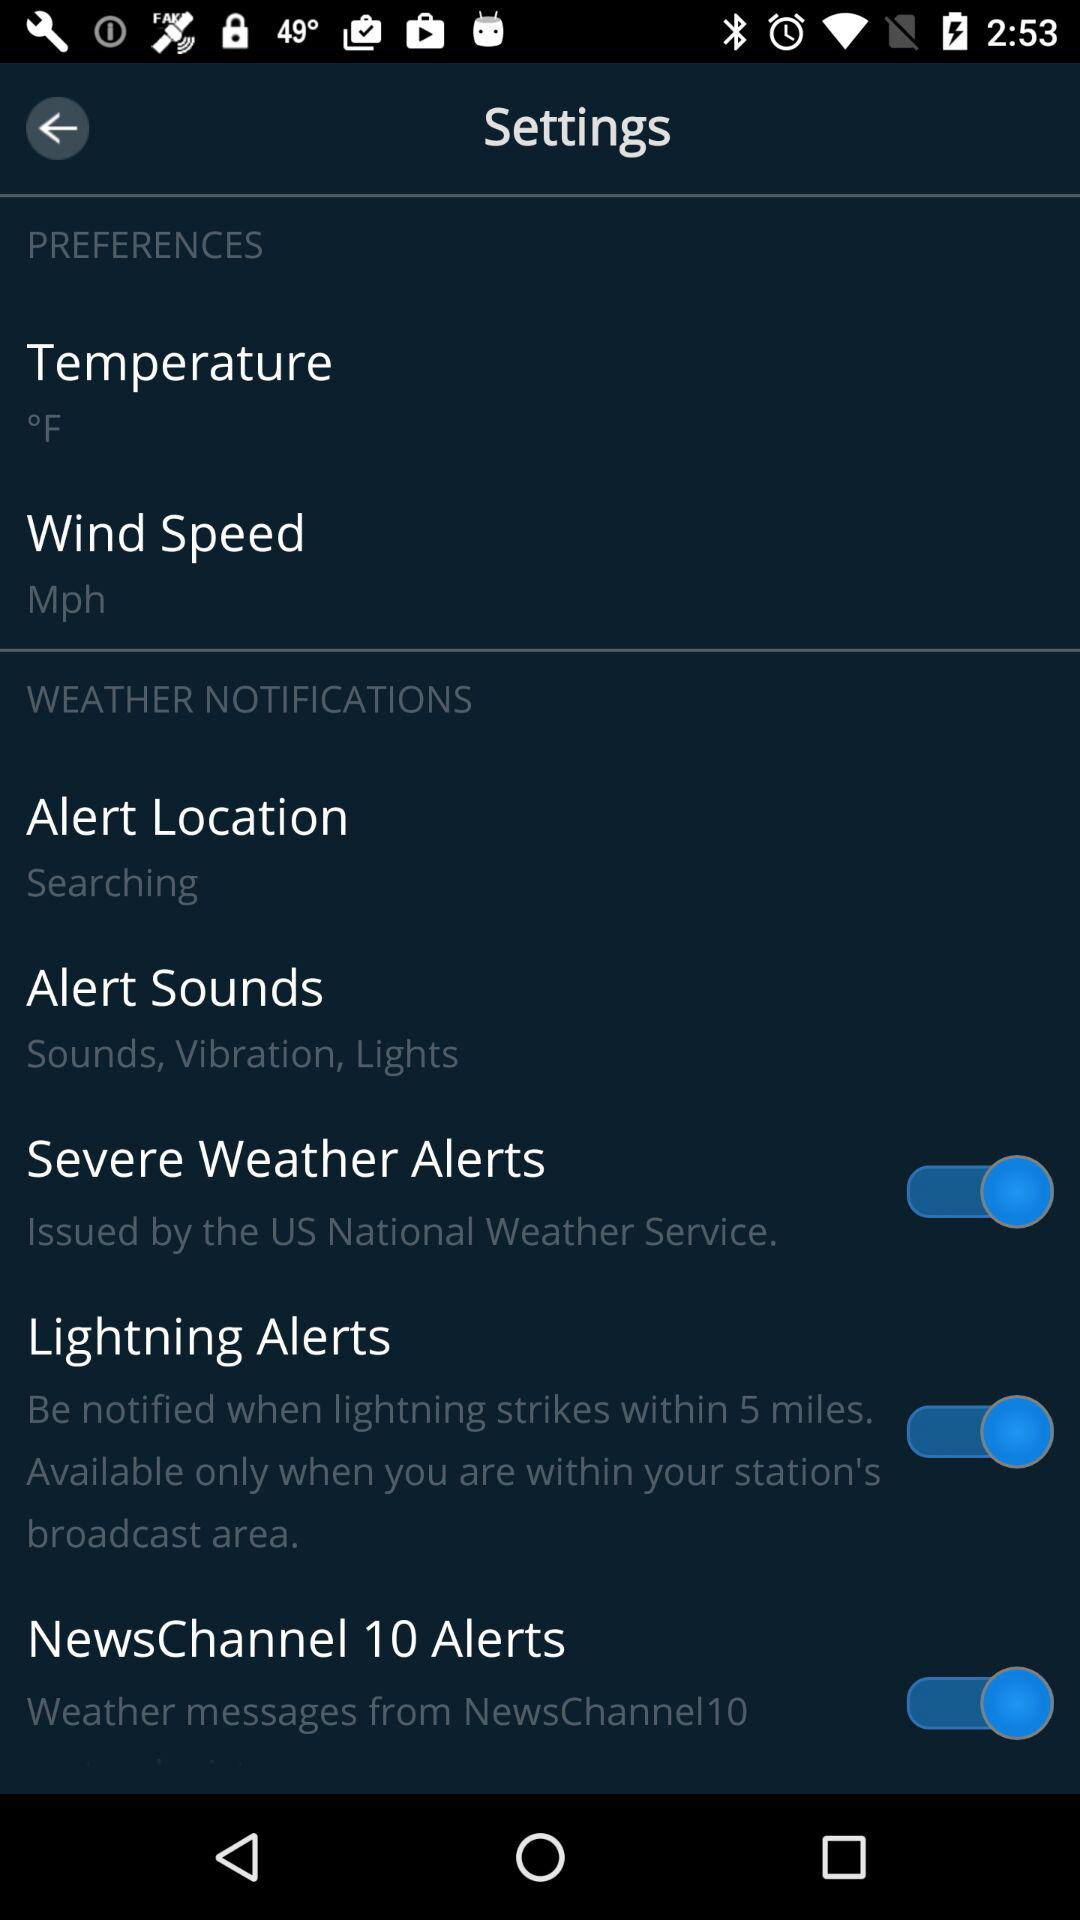What is the weather alert news channel name? The name of the weather alert news channel is "NewsChannel 10". 